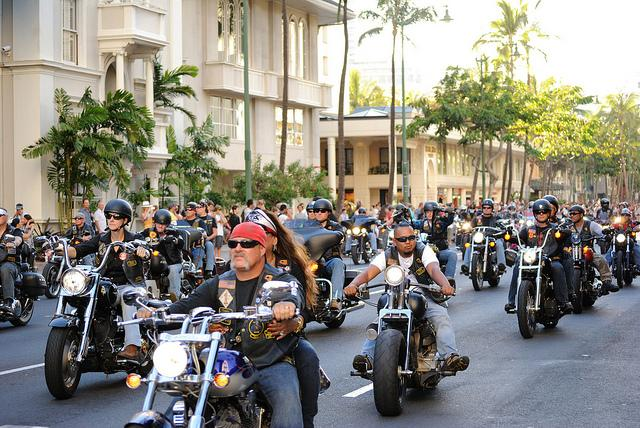What is the main reason hundreds of bikers would be riding together down a main street? Please explain your reasoning. attention. The reason is for attention. 